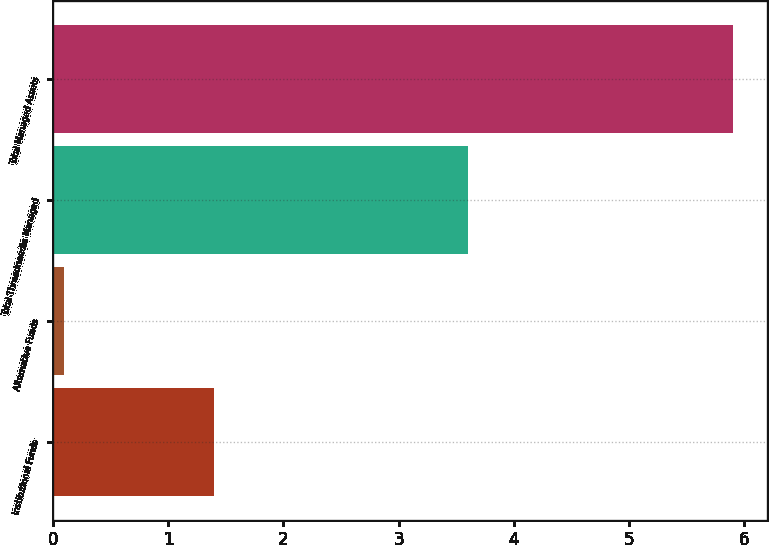Convert chart. <chart><loc_0><loc_0><loc_500><loc_500><bar_chart><fcel>Institutional Funds<fcel>Alternative Funds<fcel>Total Threadneedle Managed<fcel>Total Managed Assets<nl><fcel>1.4<fcel>0.1<fcel>3.6<fcel>5.9<nl></chart> 